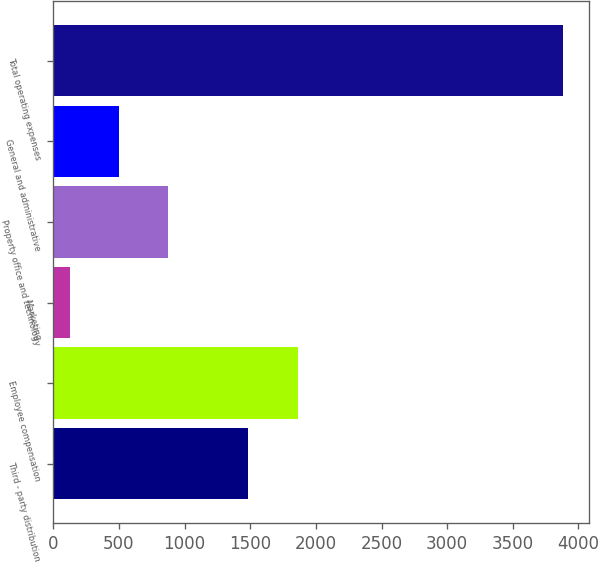Convert chart. <chart><loc_0><loc_0><loc_500><loc_500><bar_chart><fcel>Third - party distribution<fcel>Employee compensation<fcel>Marketing<fcel>Property office and technology<fcel>General and administrative<fcel>Total operating expenses<nl><fcel>1486.5<fcel>1862.45<fcel>123.7<fcel>875.6<fcel>499.65<fcel>3883.2<nl></chart> 